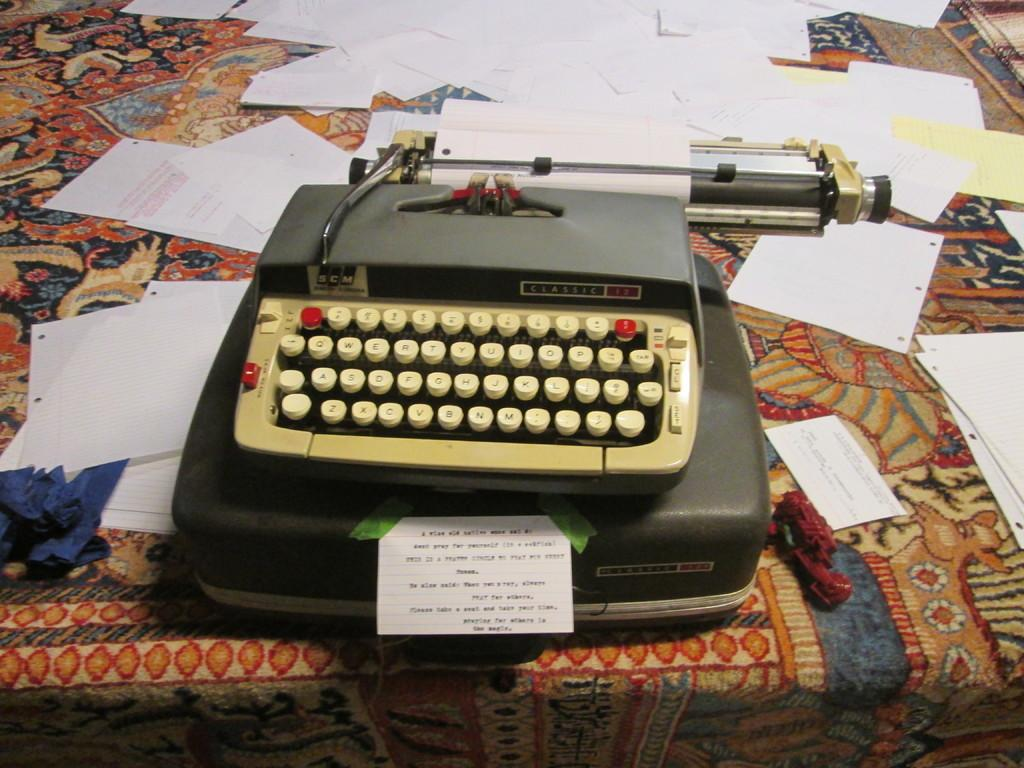<image>
Describe the image concisely. An old SCM classic typewriter is on a table with many papers. 